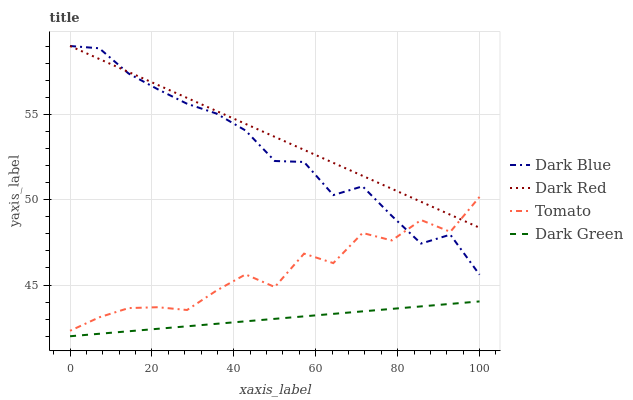Does Dark Blue have the minimum area under the curve?
Answer yes or no. No. Does Dark Blue have the maximum area under the curve?
Answer yes or no. No. Is Dark Blue the smoothest?
Answer yes or no. No. Is Dark Blue the roughest?
Answer yes or no. No. Does Dark Blue have the lowest value?
Answer yes or no. No. Does Dark Green have the highest value?
Answer yes or no. No. Is Dark Green less than Dark Blue?
Answer yes or no. Yes. Is Dark Red greater than Dark Green?
Answer yes or no. Yes. Does Dark Green intersect Dark Blue?
Answer yes or no. No. 